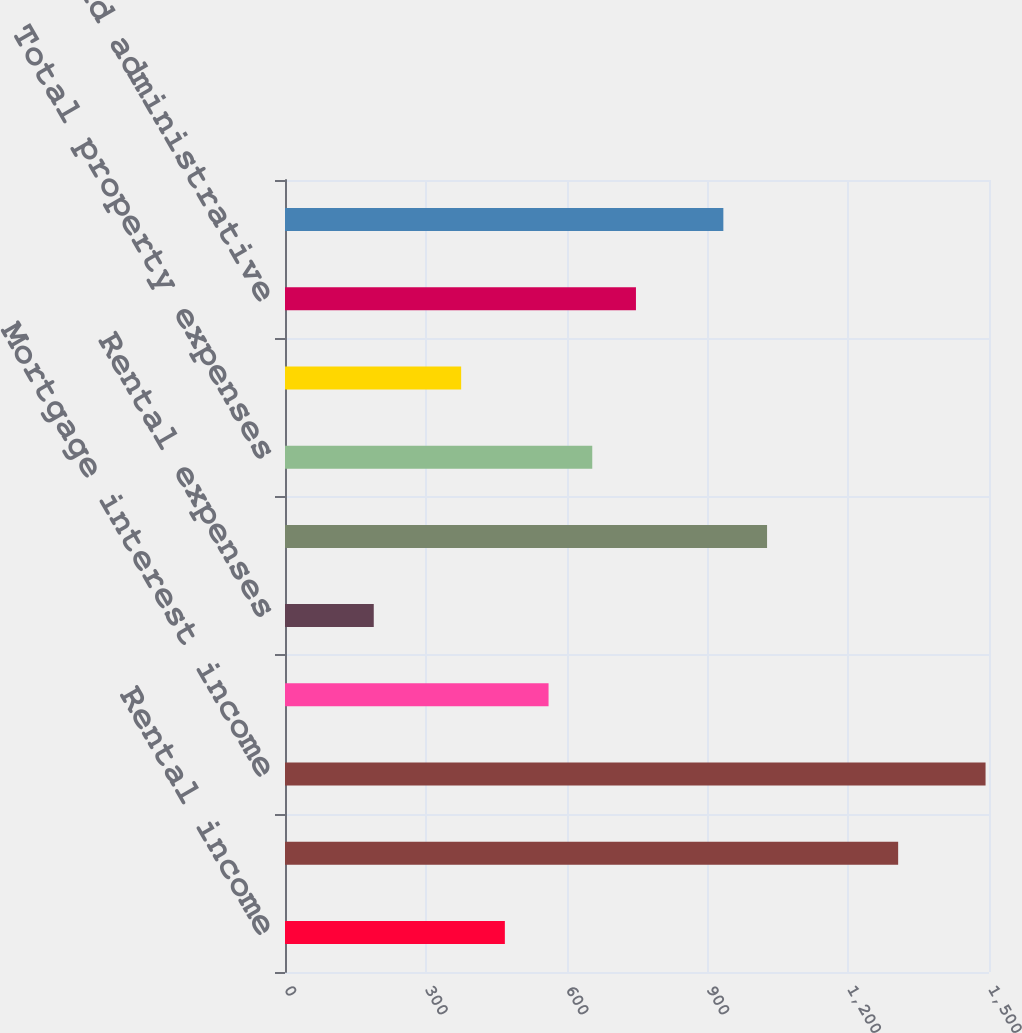Convert chart to OTSL. <chart><loc_0><loc_0><loc_500><loc_500><bar_chart><fcel>Rental income<fcel>Other property income<fcel>Mortgage interest income<fcel>Total property revenue<fcel>Rental expenses<fcel>Real estate taxes<fcel>Total property expenses<fcel>Property operating income (1)<fcel>General and administrative<fcel>Depreciation and amortization<nl><fcel>468.45<fcel>1306.44<fcel>1492.66<fcel>561.56<fcel>189.12<fcel>1027.11<fcel>654.67<fcel>375.34<fcel>747.78<fcel>934<nl></chart> 